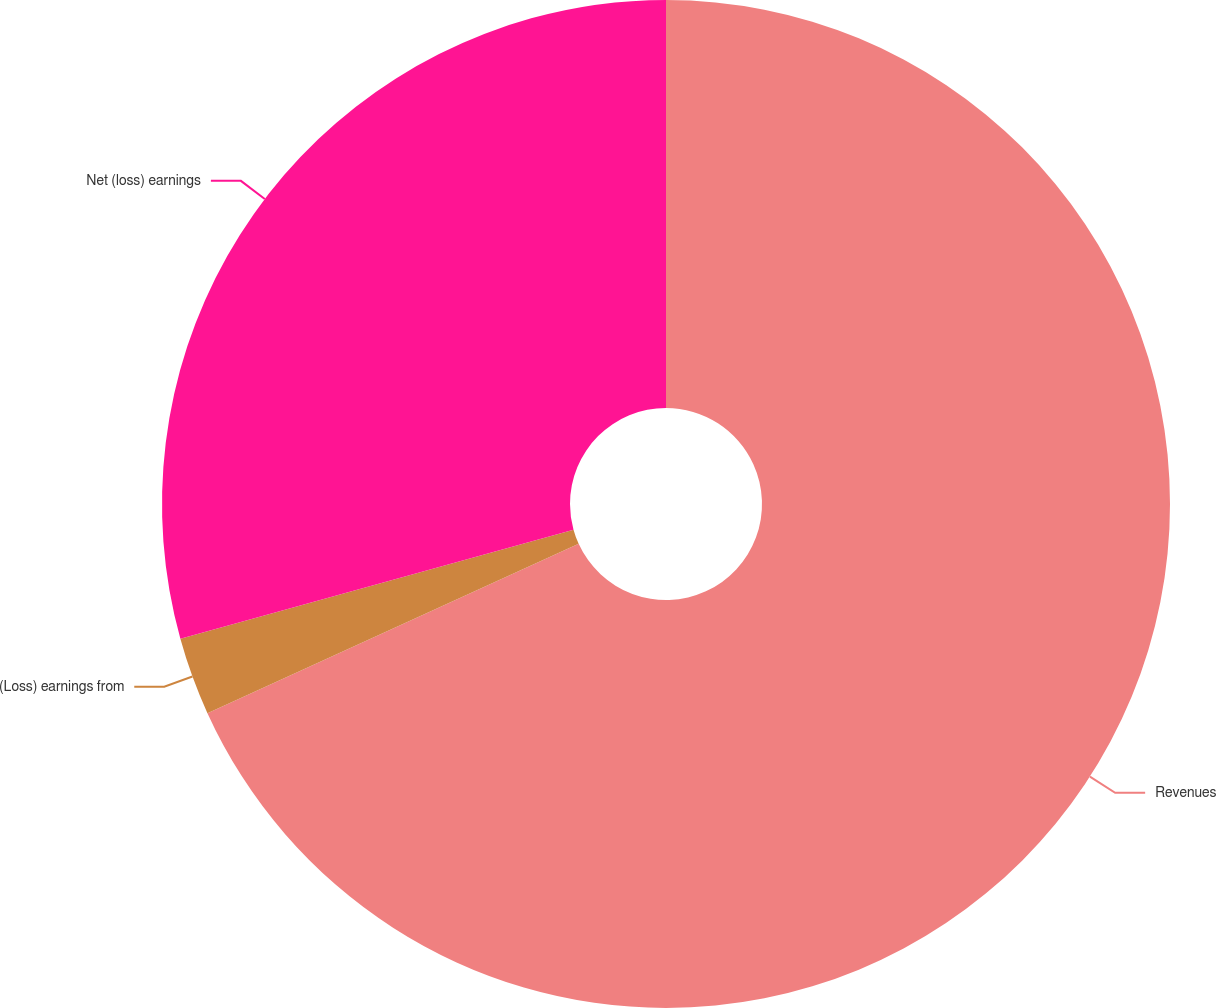Convert chart to OTSL. <chart><loc_0><loc_0><loc_500><loc_500><pie_chart><fcel>Revenues<fcel>(Loss) earnings from<fcel>Net (loss) earnings<nl><fcel>68.19%<fcel>2.5%<fcel>29.31%<nl></chart> 